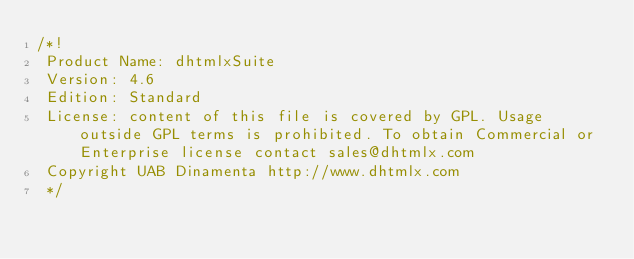<code> <loc_0><loc_0><loc_500><loc_500><_JavaScript_>/*!
 Product Name: dhtmlxSuite
 Version: 4.6
 Edition: Standard
 License: content of this file is covered by GPL. Usage outside GPL terms is prohibited. To obtain Commercial or Enterprise license contact sales@dhtmlx.com
 Copyright UAB Dinamenta http://www.dhtmlx.com
 */</code> 